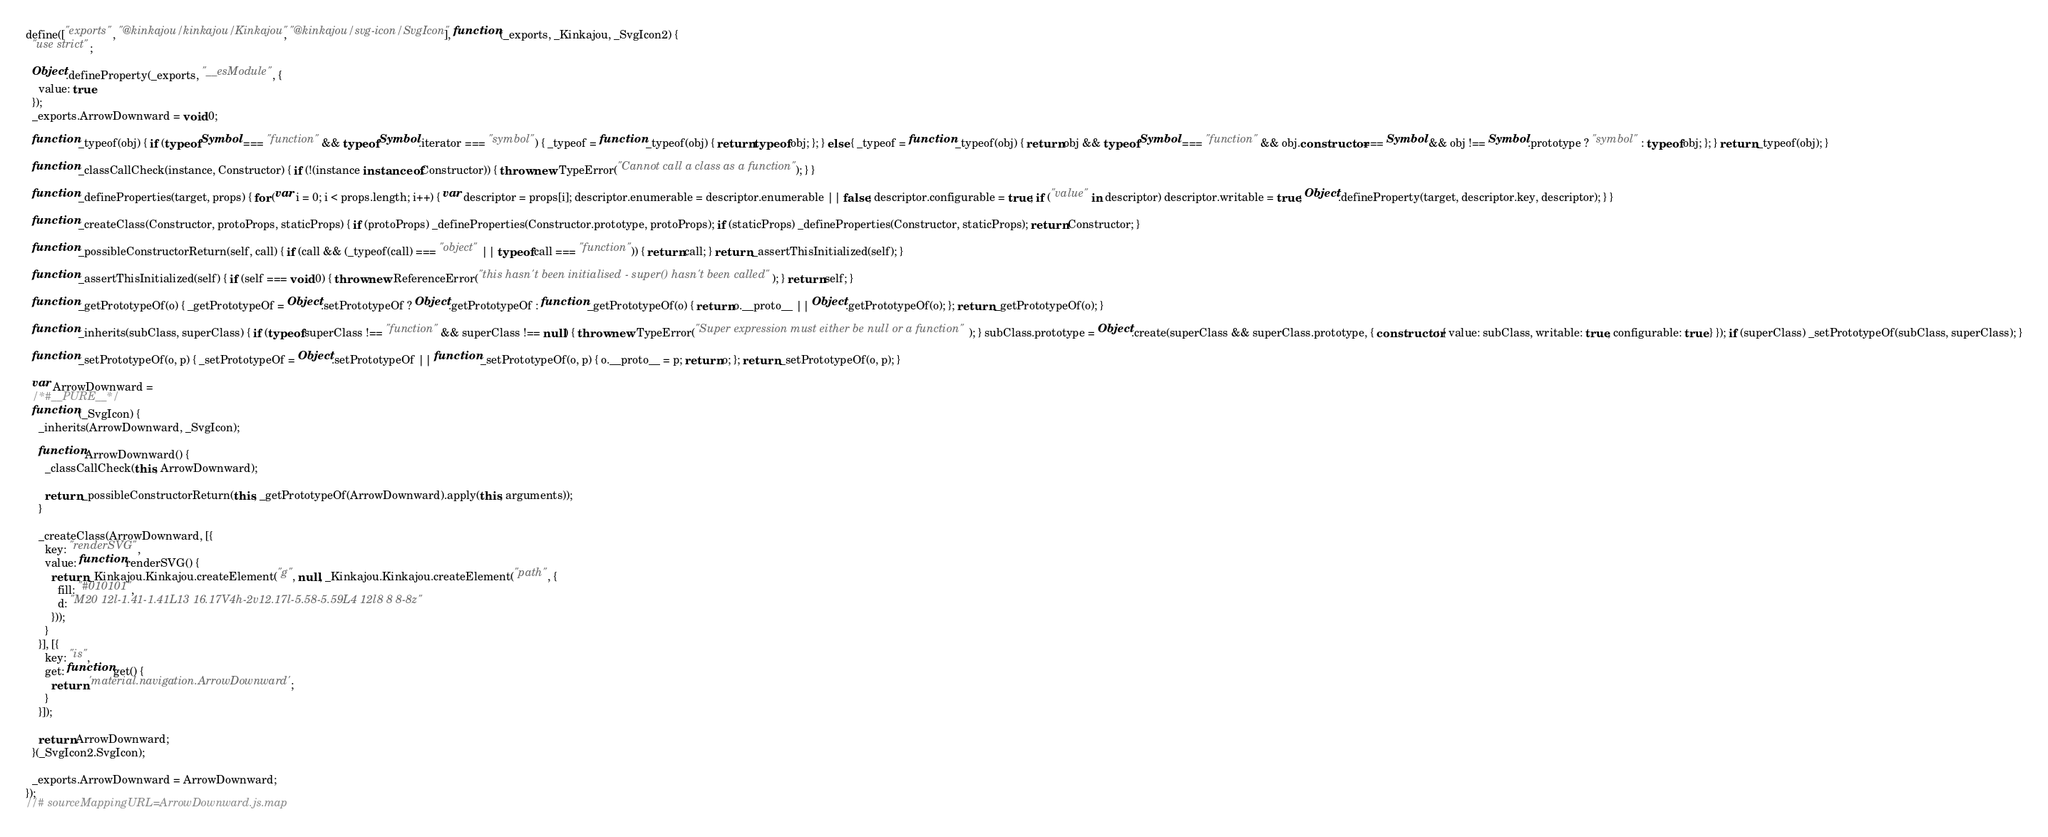Convert code to text. <code><loc_0><loc_0><loc_500><loc_500><_JavaScript_>define(["exports", "@kinkajou/kinkajou/Kinkajou", "@kinkajou/svg-icon/SvgIcon"], function (_exports, _Kinkajou, _SvgIcon2) {
  "use strict";

  Object.defineProperty(_exports, "__esModule", {
    value: true
  });
  _exports.ArrowDownward = void 0;

  function _typeof(obj) { if (typeof Symbol === "function" && typeof Symbol.iterator === "symbol") { _typeof = function _typeof(obj) { return typeof obj; }; } else { _typeof = function _typeof(obj) { return obj && typeof Symbol === "function" && obj.constructor === Symbol && obj !== Symbol.prototype ? "symbol" : typeof obj; }; } return _typeof(obj); }

  function _classCallCheck(instance, Constructor) { if (!(instance instanceof Constructor)) { throw new TypeError("Cannot call a class as a function"); } }

  function _defineProperties(target, props) { for (var i = 0; i < props.length; i++) { var descriptor = props[i]; descriptor.enumerable = descriptor.enumerable || false; descriptor.configurable = true; if ("value" in descriptor) descriptor.writable = true; Object.defineProperty(target, descriptor.key, descriptor); } }

  function _createClass(Constructor, protoProps, staticProps) { if (protoProps) _defineProperties(Constructor.prototype, protoProps); if (staticProps) _defineProperties(Constructor, staticProps); return Constructor; }

  function _possibleConstructorReturn(self, call) { if (call && (_typeof(call) === "object" || typeof call === "function")) { return call; } return _assertThisInitialized(self); }

  function _assertThisInitialized(self) { if (self === void 0) { throw new ReferenceError("this hasn't been initialised - super() hasn't been called"); } return self; }

  function _getPrototypeOf(o) { _getPrototypeOf = Object.setPrototypeOf ? Object.getPrototypeOf : function _getPrototypeOf(o) { return o.__proto__ || Object.getPrototypeOf(o); }; return _getPrototypeOf(o); }

  function _inherits(subClass, superClass) { if (typeof superClass !== "function" && superClass !== null) { throw new TypeError("Super expression must either be null or a function"); } subClass.prototype = Object.create(superClass && superClass.prototype, { constructor: { value: subClass, writable: true, configurable: true } }); if (superClass) _setPrototypeOf(subClass, superClass); }

  function _setPrototypeOf(o, p) { _setPrototypeOf = Object.setPrototypeOf || function _setPrototypeOf(o, p) { o.__proto__ = p; return o; }; return _setPrototypeOf(o, p); }

  var ArrowDownward =
  /*#__PURE__*/
  function (_SvgIcon) {
    _inherits(ArrowDownward, _SvgIcon);

    function ArrowDownward() {
      _classCallCheck(this, ArrowDownward);

      return _possibleConstructorReturn(this, _getPrototypeOf(ArrowDownward).apply(this, arguments));
    }

    _createClass(ArrowDownward, [{
      key: "renderSVG",
      value: function renderSVG() {
        return _Kinkajou.Kinkajou.createElement("g", null, _Kinkajou.Kinkajou.createElement("path", {
          fill: "#010101",
          d: "M20 12l-1.41-1.41L13 16.17V4h-2v12.17l-5.58-5.59L4 12l8 8 8-8z"
        }));
      }
    }], [{
      key: "is",
      get: function get() {
        return 'material.navigation.ArrowDownward';
      }
    }]);

    return ArrowDownward;
  }(_SvgIcon2.SvgIcon);

  _exports.ArrowDownward = ArrowDownward;
});
//# sourceMappingURL=ArrowDownward.js.map</code> 